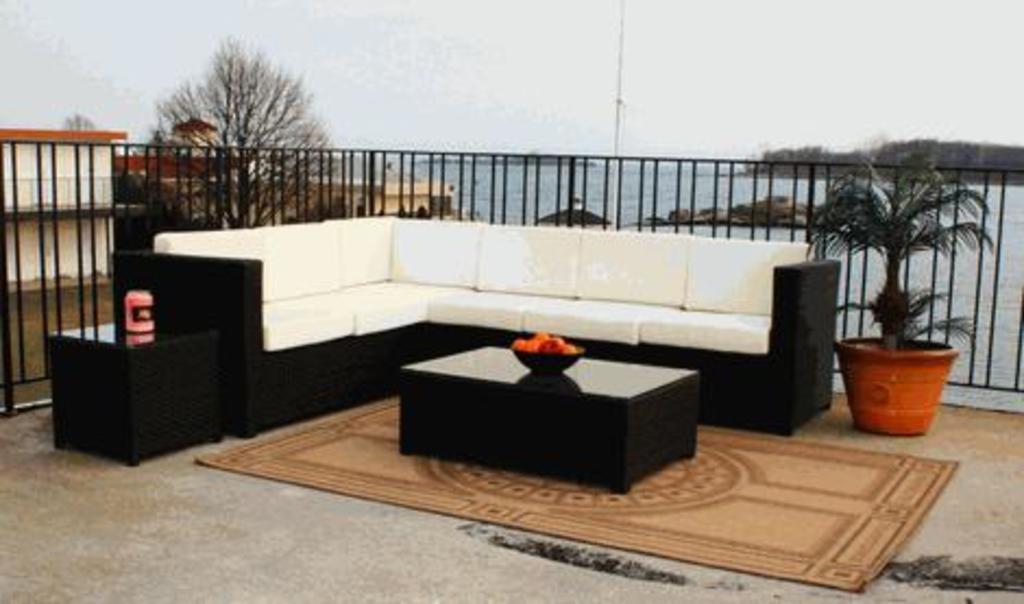In one or two sentences, can you explain what this image depicts? In this image I can see couch which is in white and black color. In front I can see table and bowl. I can see something in it. We can see flower pot and a floor mat. Back Side I can see buildings,trees and fencing. We can see water and a pole. The sky is in white color. 